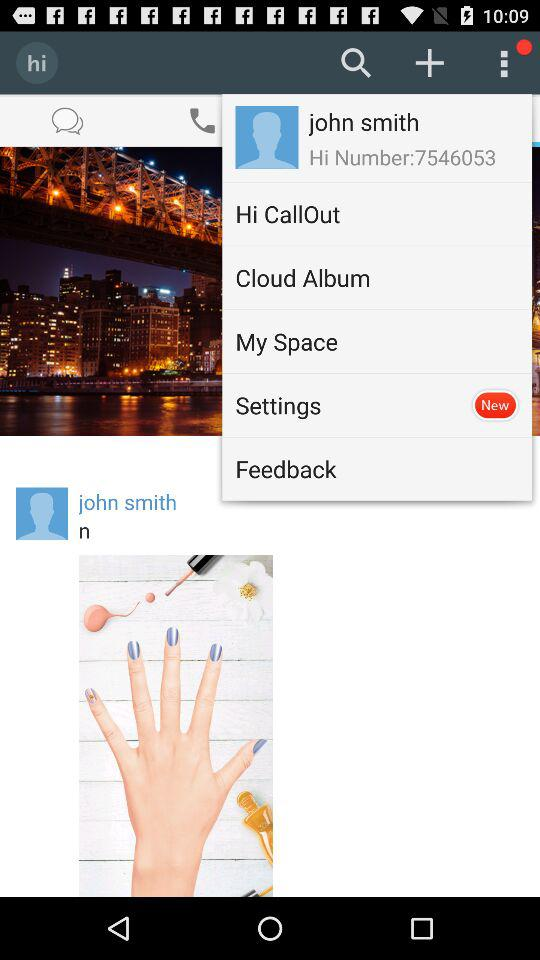What is the name of the application? The name of the application is "hi". 